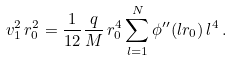<formula> <loc_0><loc_0><loc_500><loc_500>v _ { 1 } ^ { 2 } \, r _ { 0 } ^ { 2 } = \frac { 1 } { 1 2 } \frac { q } { M } \, r _ { 0 } ^ { 4 } \sum _ { l = 1 } ^ { N } \phi ^ { \prime \prime } ( l r _ { 0 } ) \, l ^ { 4 } \, .</formula> 